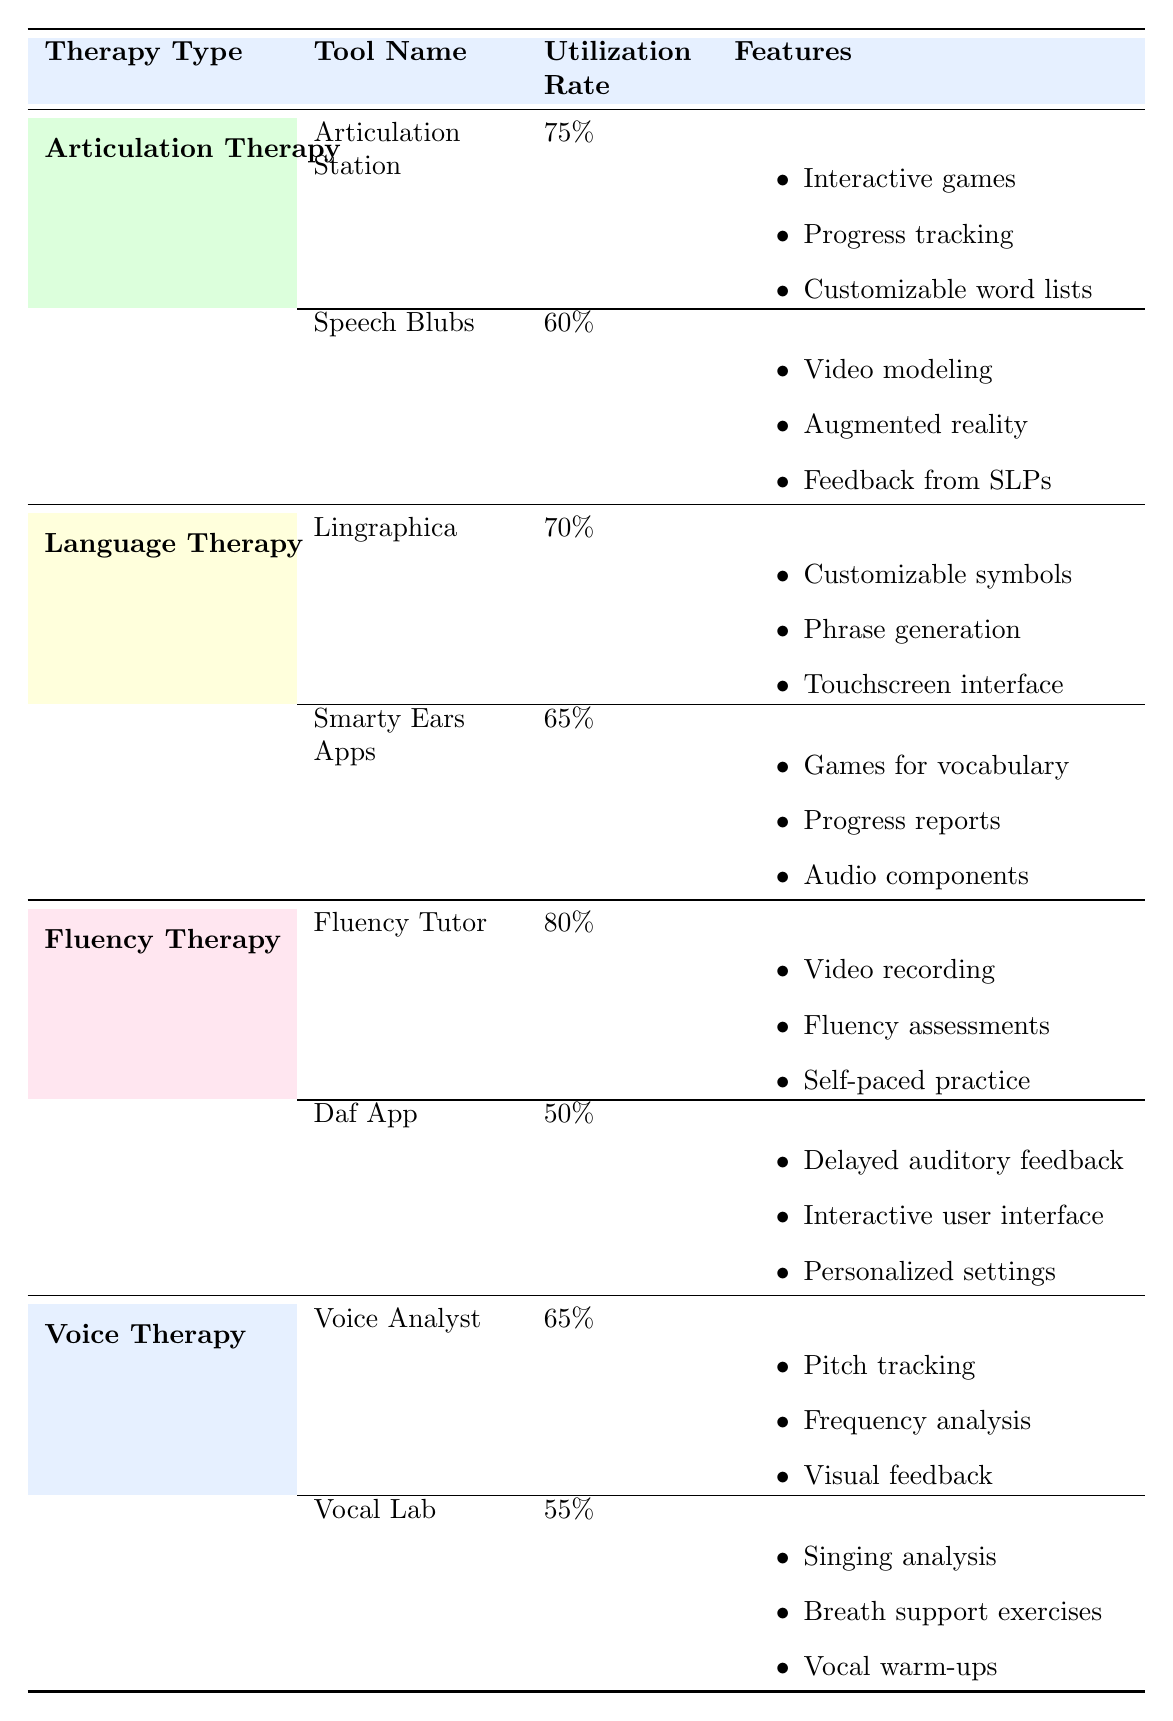What is the utilization rate of the Articulation Station? The utilization rate for the Articulation Station is listed in the table under the corresponding tool. It shows 75% in the respective column.
Answer: 75% Which therapy tool has the highest utilization rate? We compare the utilization rates from each therapy type: Articulation Therapy has 75% and 60%, Language Therapy has 70% and 65%, Fluency Therapy has 80% and 50%, and Voice Therapy has 65% and 55%. The highest rate of 80% is from the Fluency Tutor.
Answer: 80% Is the Daf App utilized more than 60%? The utilization rate for the Daf App is 50%. Since 50% is less than 60%, the answer is no.
Answer: No What are the features of the Lingraphica tool? The features of the Lingraphica tool are listed directly under the tool in the table: customizable symbols, phrase generation, and touchscreen interface.
Answer: Customizable symbols, phrase generation, touchscreen interface What is the average utilization rate across all therapy tools? To find the average, we first list the utilization rates: 75%, 60%, 70%, 65%, 80%, 50%, 65%, and 55%. We convert these percentages to numerical values for calculation: 75, 60, 70, 65, 80, 50, 65, and 55 gives us a total of 575. There are 8 data points, so we divide: 575 / 8 = 71.875. This leads us to conclude that the average utilization rate is 71.875%.
Answer: 71.875% Does the Voice Analyst tool have any features related to pitch tracking? The features of the Voice Analyst tool are listed, which include pitch tracking, frequency analysis, and visual feedback. Therefore, the answer is yes.
Answer: Yes 